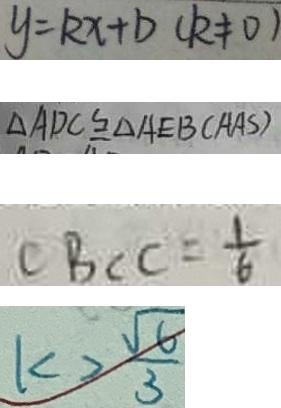<formula> <loc_0><loc_0><loc_500><loc_500>y = k x + b ( k \neq 0 ) 
 \Delta A D C \cong \Delta A E B ( A A S ) 
 C B C C = \frac { 1 } { 6 } 
 k > \frac { \sqrt { 6 } } { 3 }</formula> 